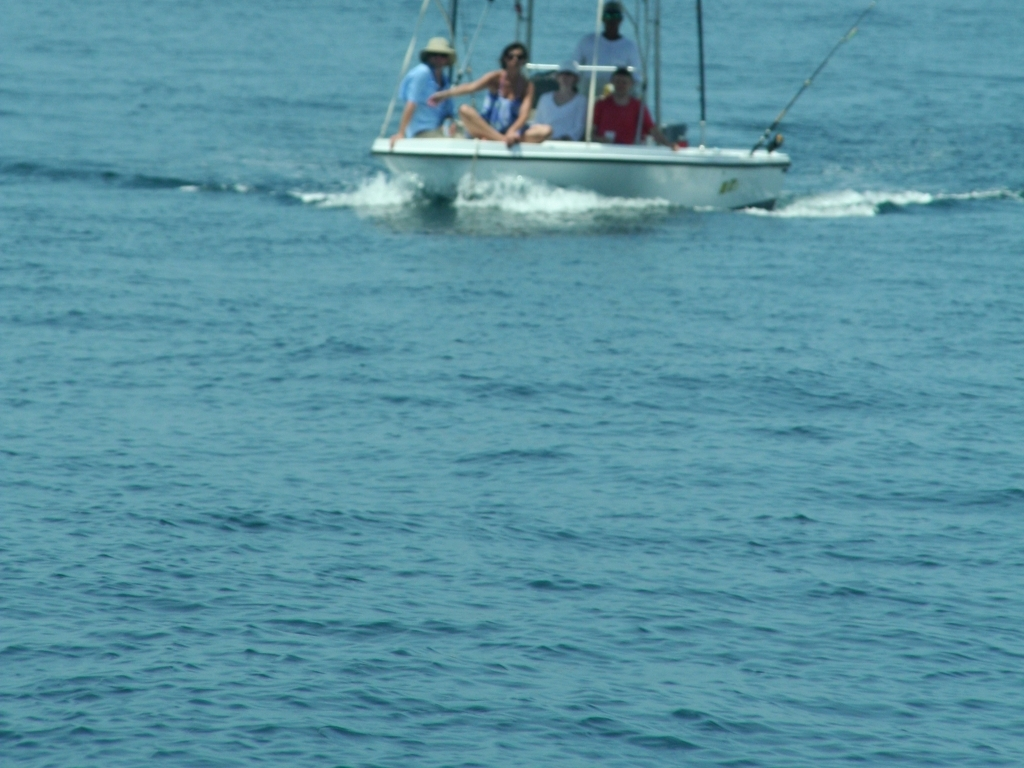Can you estimate how many people are on the boat? It's a bit challenging to distinguish due to the blurriness of the image, but it seems like there are at least three individuals on board the boat, participating in the activity together. What type of boat is shown in the image? The boat appears to be a small motorboat, suitable for a group of recreational fishers. It's designed to navigate waters for leisure activities like fishing, as evident from its size and the arrangement seen in the image. 